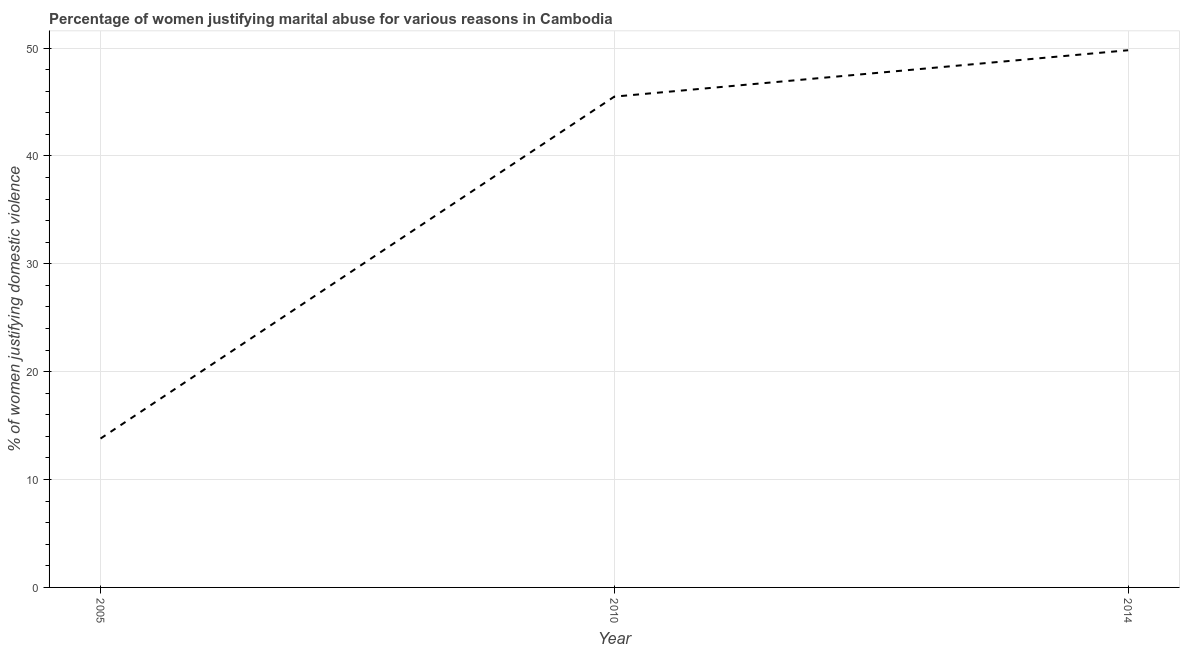What is the percentage of women justifying marital abuse in 2014?
Provide a short and direct response. 49.8. Across all years, what is the maximum percentage of women justifying marital abuse?
Provide a short and direct response. 49.8. What is the sum of the percentage of women justifying marital abuse?
Make the answer very short. 109.1. What is the difference between the percentage of women justifying marital abuse in 2005 and 2010?
Keep it short and to the point. -31.7. What is the average percentage of women justifying marital abuse per year?
Make the answer very short. 36.37. What is the median percentage of women justifying marital abuse?
Make the answer very short. 45.5. In how many years, is the percentage of women justifying marital abuse greater than 46 %?
Keep it short and to the point. 1. Do a majority of the years between 2005 and 2014 (inclusive) have percentage of women justifying marital abuse greater than 48 %?
Keep it short and to the point. No. What is the ratio of the percentage of women justifying marital abuse in 2005 to that in 2010?
Offer a very short reply. 0.3. Is the percentage of women justifying marital abuse in 2010 less than that in 2014?
Keep it short and to the point. Yes. Is the difference between the percentage of women justifying marital abuse in 2005 and 2010 greater than the difference between any two years?
Your answer should be very brief. No. What is the difference between the highest and the second highest percentage of women justifying marital abuse?
Provide a succinct answer. 4.3. Is the sum of the percentage of women justifying marital abuse in 2010 and 2014 greater than the maximum percentage of women justifying marital abuse across all years?
Keep it short and to the point. Yes. How many years are there in the graph?
Provide a short and direct response. 3. What is the difference between two consecutive major ticks on the Y-axis?
Provide a short and direct response. 10. Does the graph contain grids?
Offer a terse response. Yes. What is the title of the graph?
Offer a terse response. Percentage of women justifying marital abuse for various reasons in Cambodia. What is the label or title of the Y-axis?
Your answer should be compact. % of women justifying domestic violence. What is the % of women justifying domestic violence of 2005?
Your answer should be compact. 13.8. What is the % of women justifying domestic violence of 2010?
Your response must be concise. 45.5. What is the % of women justifying domestic violence in 2014?
Offer a terse response. 49.8. What is the difference between the % of women justifying domestic violence in 2005 and 2010?
Offer a terse response. -31.7. What is the difference between the % of women justifying domestic violence in 2005 and 2014?
Give a very brief answer. -36. What is the ratio of the % of women justifying domestic violence in 2005 to that in 2010?
Make the answer very short. 0.3. What is the ratio of the % of women justifying domestic violence in 2005 to that in 2014?
Your answer should be compact. 0.28. What is the ratio of the % of women justifying domestic violence in 2010 to that in 2014?
Give a very brief answer. 0.91. 